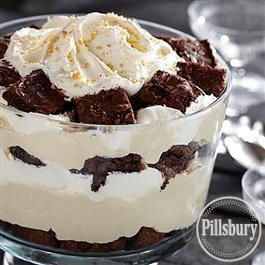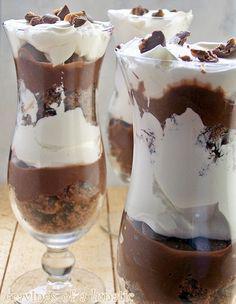The first image is the image on the left, the second image is the image on the right. For the images shown, is this caption "There is one layered dessert in each image, and they are both in dishes with stems." true? Answer yes or no. No. 